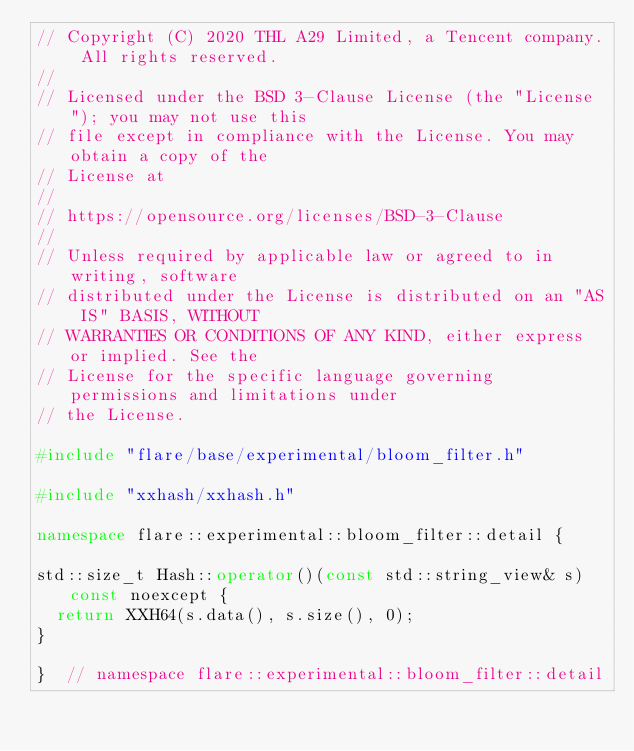<code> <loc_0><loc_0><loc_500><loc_500><_C++_>// Copyright (C) 2020 THL A29 Limited, a Tencent company. All rights reserved.
//
// Licensed under the BSD 3-Clause License (the "License"); you may not use this
// file except in compliance with the License. You may obtain a copy of the
// License at
//
// https://opensource.org/licenses/BSD-3-Clause
//
// Unless required by applicable law or agreed to in writing, software
// distributed under the License is distributed on an "AS IS" BASIS, WITHOUT
// WARRANTIES OR CONDITIONS OF ANY KIND, either express or implied. See the
// License for the specific language governing permissions and limitations under
// the License.

#include "flare/base/experimental/bloom_filter.h"

#include "xxhash/xxhash.h"

namespace flare::experimental::bloom_filter::detail {

std::size_t Hash::operator()(const std::string_view& s) const noexcept {
  return XXH64(s.data(), s.size(), 0);
}

}  // namespace flare::experimental::bloom_filter::detail
</code> 